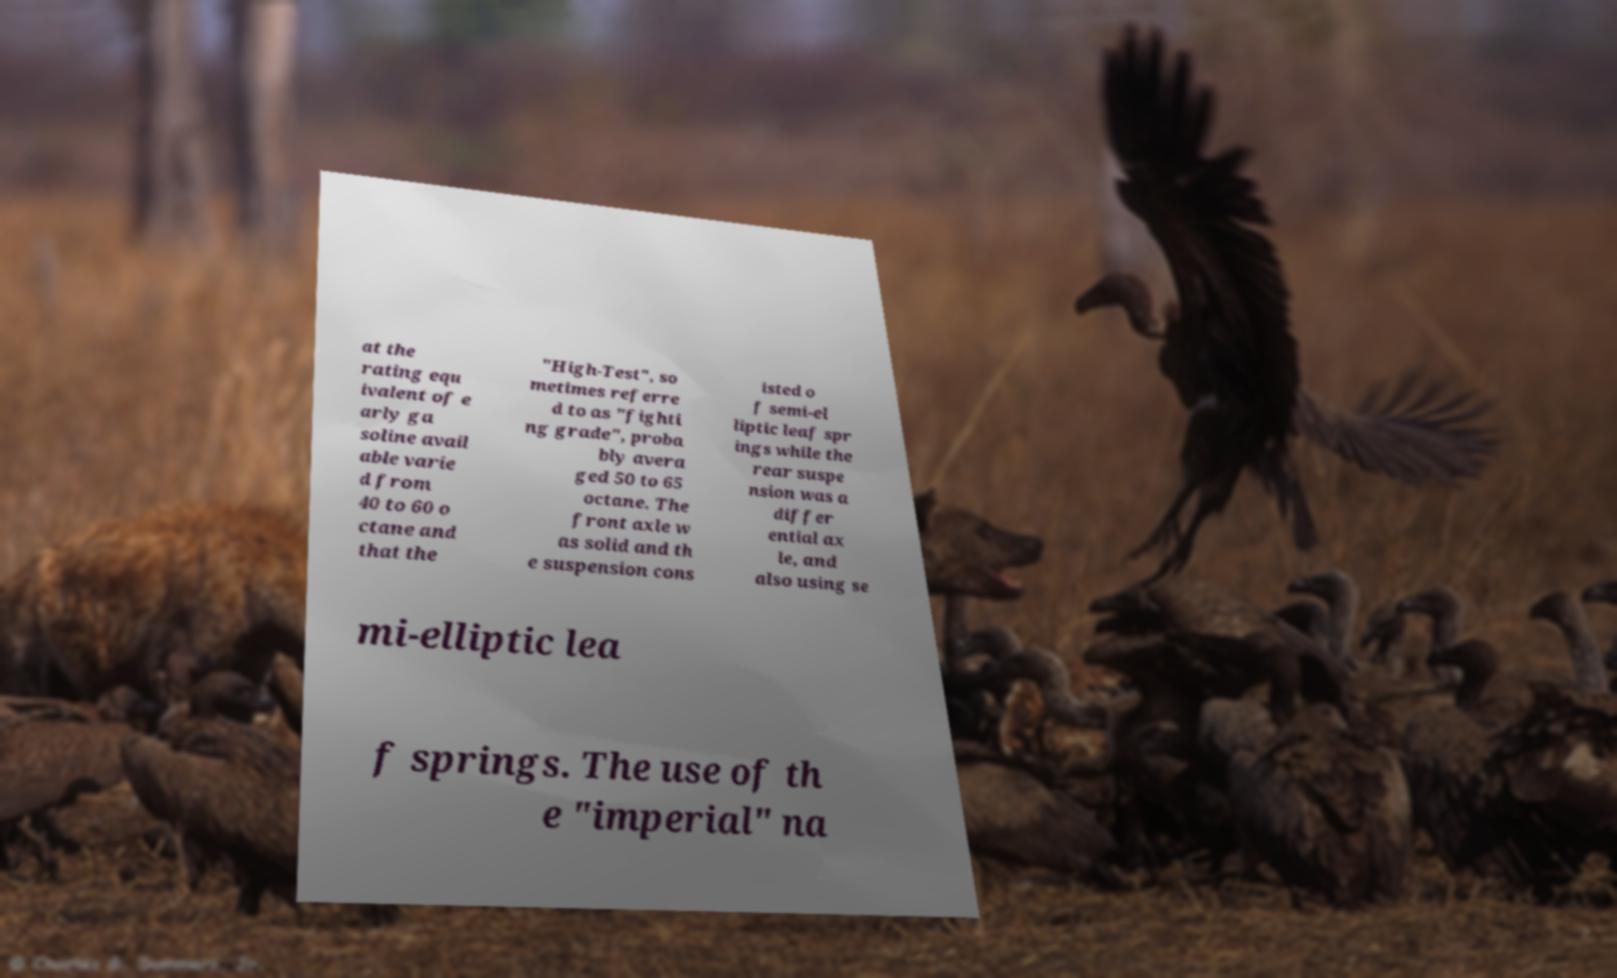What messages or text are displayed in this image? I need them in a readable, typed format. at the rating equ ivalent of e arly ga soline avail able varie d from 40 to 60 o ctane and that the "High-Test", so metimes referre d to as "fighti ng grade", proba bly avera ged 50 to 65 octane. The front axle w as solid and th e suspension cons isted o f semi-el liptic leaf spr ings while the rear suspe nsion was a differ ential ax le, and also using se mi-elliptic lea f springs. The use of th e "imperial" na 